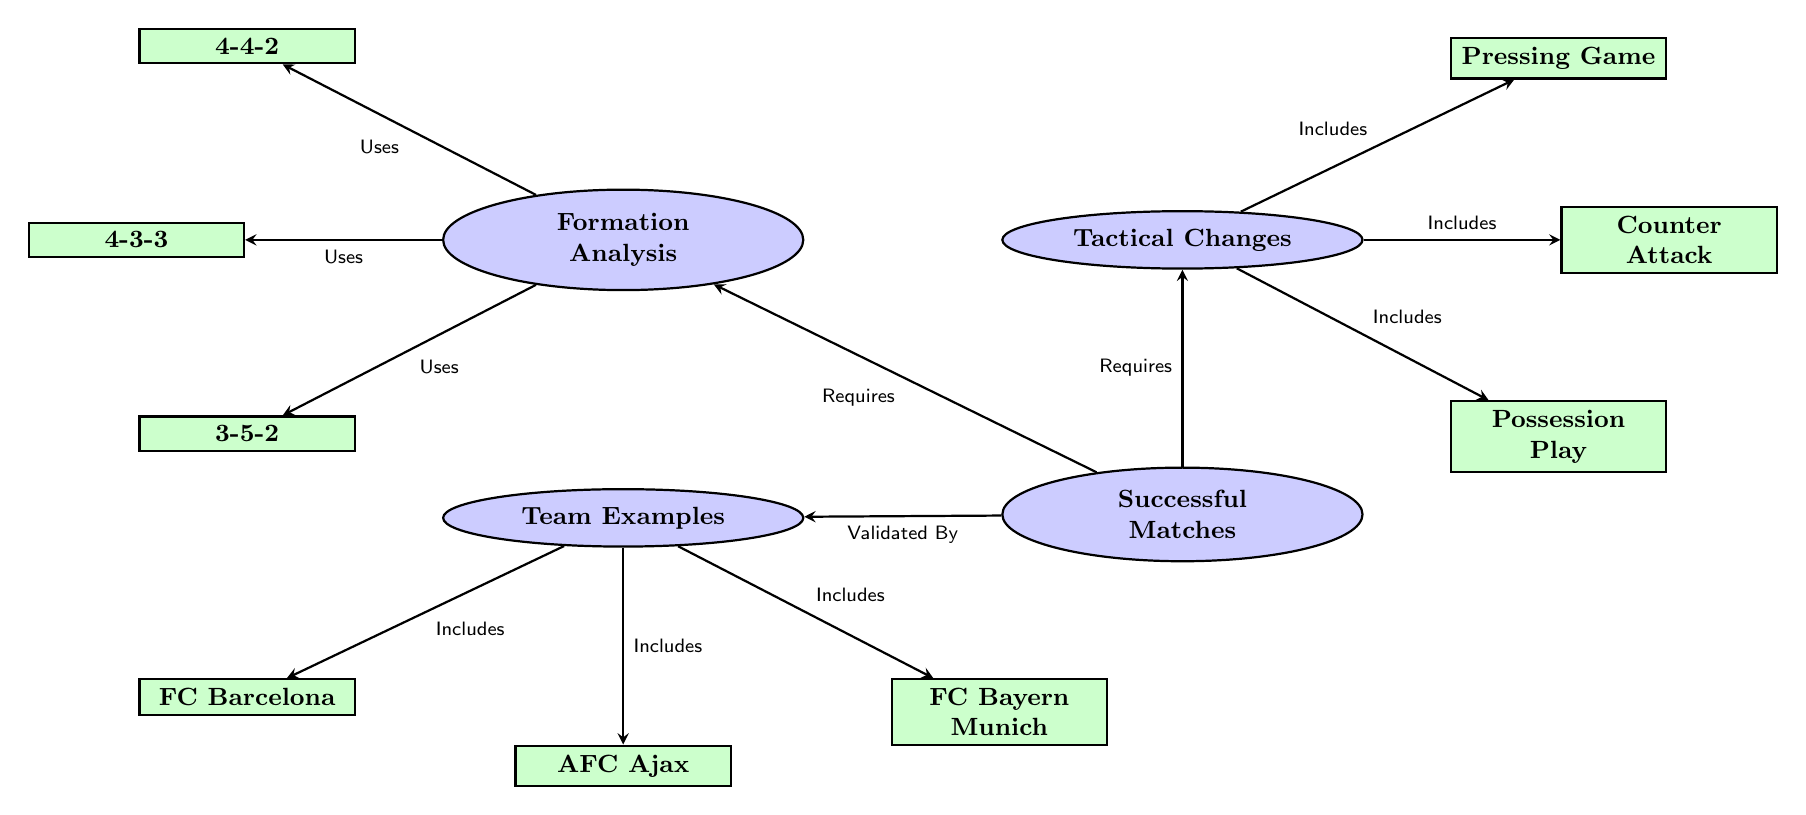What nodes are included in the formation analysis? The diagram shows three nodes under formation analysis: 4-4-2, 4-3-3, and 3-5-2. These nodes represent various football formations used in matches.
Answer: 4-4-2, 4-3-3, 3-5-2 How many tactical changes are listed? The diagram features three tactical changes: Pressing Game, Counter Attack, and Possession Play. These are categorized as tactical changes that help enhance team performance.
Answer: 3 What is at the bottom of the tactical changes node? The node directly below the tactical changes node is Successful Matches, indicating that tactical changes are necessary for achieving match success.
Answer: Successful Matches Which team is listed as an example of successful matches? The examples node includes three teams: FC Barcelona, AFC Ajax, and FC Bayern Munich, as successful instances of teams using formation and tactical changes effectively.
Answer: FC Barcelona What is the relationship between successful matches and formation? The edge indicates that successful matches require formation analysis, suggesting that the correct formation is a prerequisite for success in matches.
Answer: Requires How many edges are connected to the tactical changes node? The tactical changes node has three edges connecting to it, each representing one specific tactical change. This indicates that it is a key area with different tactical strategies.
Answer: 3 Which formation includes the 3-5-2 strategy? The 3-5-2 strategy is listed under the formation analysis node, indicating that it is one of the formations being analyzed for tactical effectiveness, but no specific team is associated with it in the diagram.
Answer: 3-5-2 What does the successful matches node validate? The successful matches node is validated by examples, namely the teams listed below it, which demonstrate the effectiveness of the formations and tactics used in successful matches.
Answer: Examples 